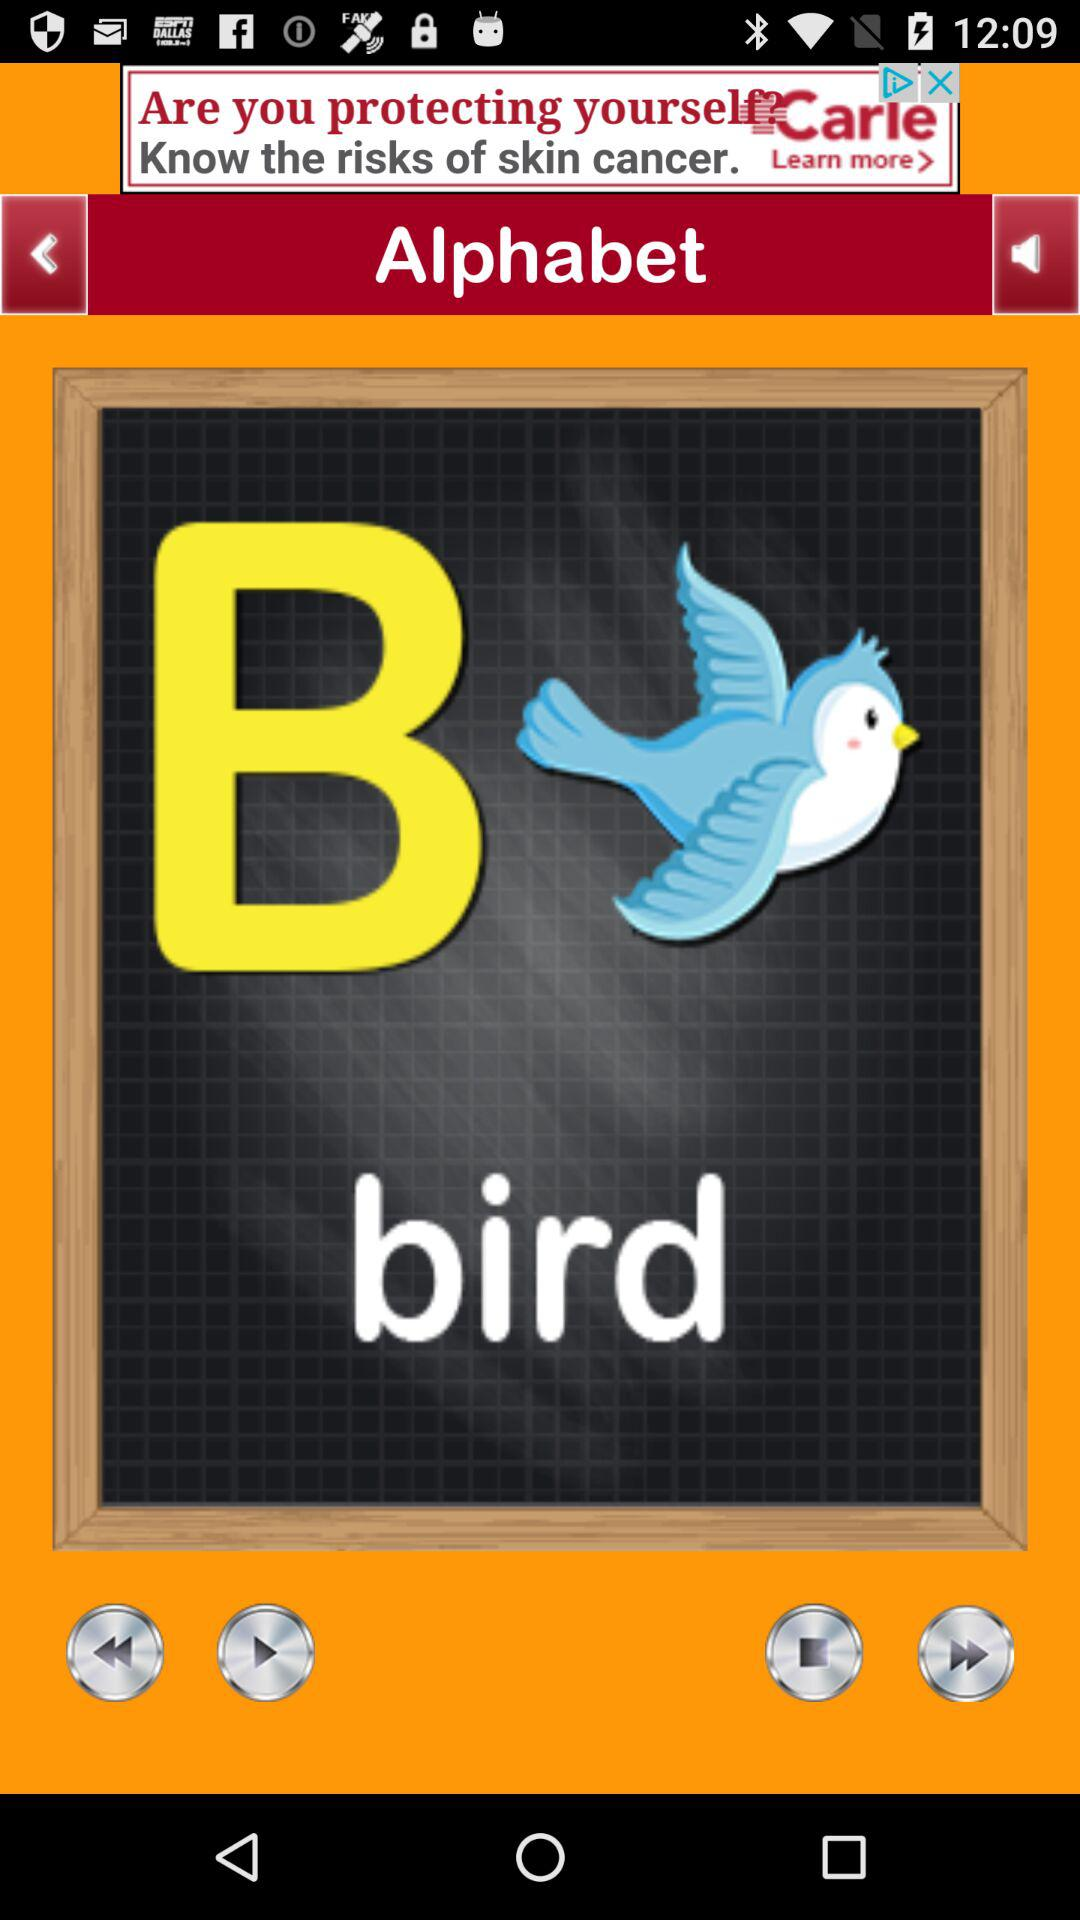Which alphabet is shown? The shown alphabet is "B". 